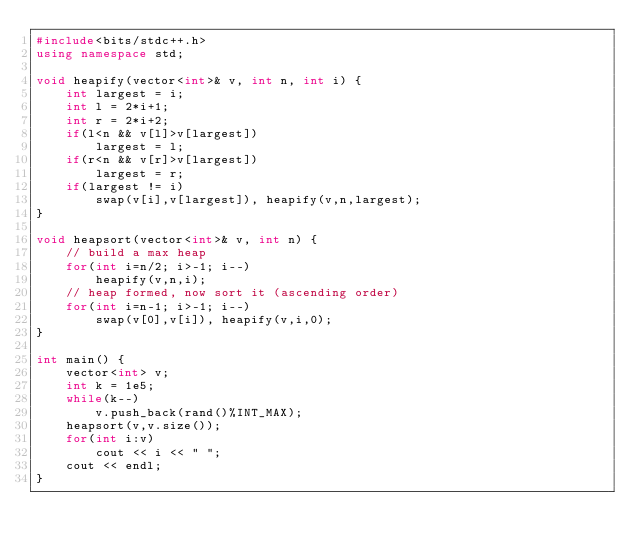Convert code to text. <code><loc_0><loc_0><loc_500><loc_500><_C++_>#include<bits/stdc++.h>
using namespace std;

void heapify(vector<int>& v, int n, int i) {
	int largest = i;
	int l = 2*i+1;
	int r = 2*i+2;
	if(l<n && v[l]>v[largest])
		largest = l;
	if(r<n && v[r]>v[largest])
		largest = r;
	if(largest != i)
		swap(v[i],v[largest]), heapify(v,n,largest);
}

void heapsort(vector<int>& v, int n) {
	// build a max heap
	for(int i=n/2; i>-1; i--)
		heapify(v,n,i);
	// heap formed, now sort it (ascending order)
	for(int i=n-1; i>-1; i--)
		swap(v[0],v[i]), heapify(v,i,0);
}

int main() {
	vector<int> v;
	int k = 1e5;
	while(k--)
		v.push_back(rand()%INT_MAX);
	heapsort(v,v.size());
	for(int i:v)
		cout << i << " ";
	cout << endl;
}
</code> 